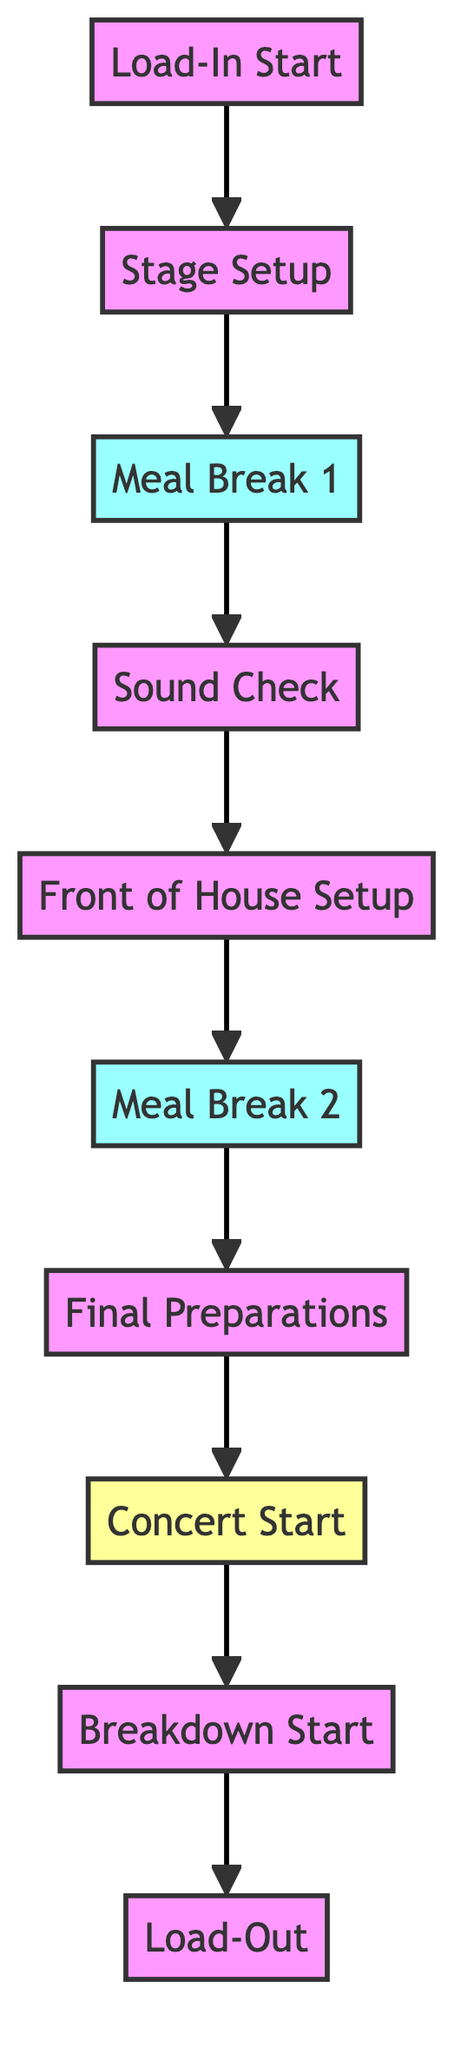What's the first step in the process? The diagram indicates that the first step is "Load-In Start," which is the initiating point of the entire sequence.
Answer: Load-In Start How many meal breaks are shown in the diagram? There are two meal breaks indicated in the flowchart, as labeled "Meal Break 1" and "Meal Break 2."
Answer: 2 What follows "Final Preparations"? According to the diagram, after "Final Preparations," the next stage is "Concert Start."
Answer: Concert Start What are the last two steps in the process? The final two steps in the sequence are "Breakdown Start" followed by "Load-Out."
Answer: Breakdown Start, Load-Out What step occurs after "Sound Check"? The step that occurs immediately after "Sound Check" is "Front of House Setup."
Answer: Front of House Setup What is the relationship between "Stage Setup" and the first meal break? "Stage Setup" leads directly to "Meal Break 1," indicating that meal break follows the stage setup.
Answer: leads to Which step is the only one labeled as a concert? The only step labeled specifically as a concert is "Concert Start."
Answer: Concert Start How many nodes are present in total in this flowchart? By counting each labeled step in the flowchart, there are a total of nine labeled nodes represented.
Answer: 9 What would happen immediately after "Load-In Start"? Following "Load-In Start," the next action is "Stage Setup," which is the immediate next step in the process.
Answer: Stage Setup What happens after "Meal Break 2"? After "Meal Break 2," the activity that follows is "Final Preparations."
Answer: Final Preparations 